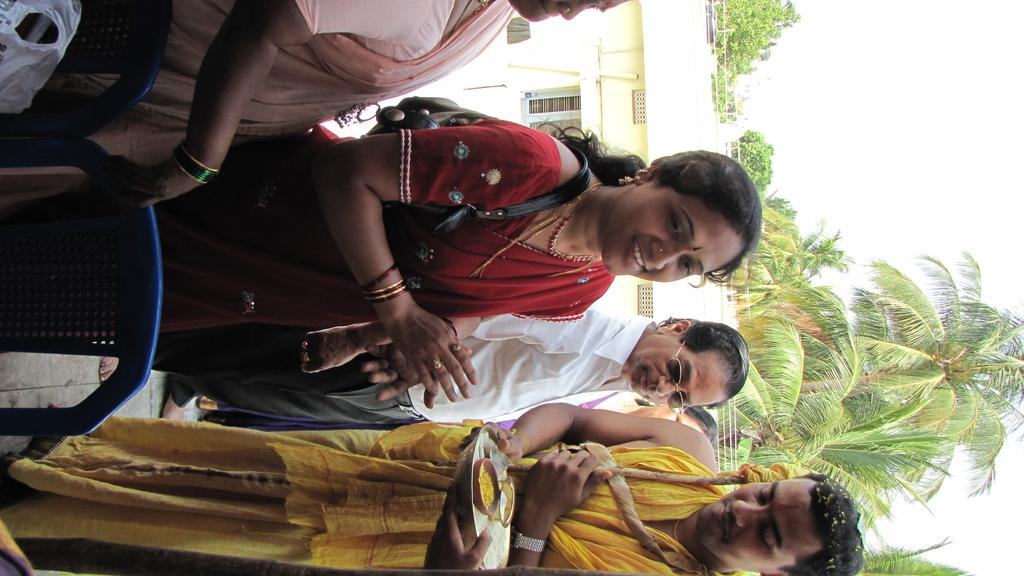What can be seen on the left side of the image? There are people on the left side of the image. What is visible in the background of the image? There are buildings and trees in the background of the image. What type of prose is being recited by the people on the left side of the image? There is no indication in the image that the people are reciting any prose. Can you tell me how many eggs are visible in the pockets of the people on the left side of the image? There are no eggs or pockets visible in the image. 